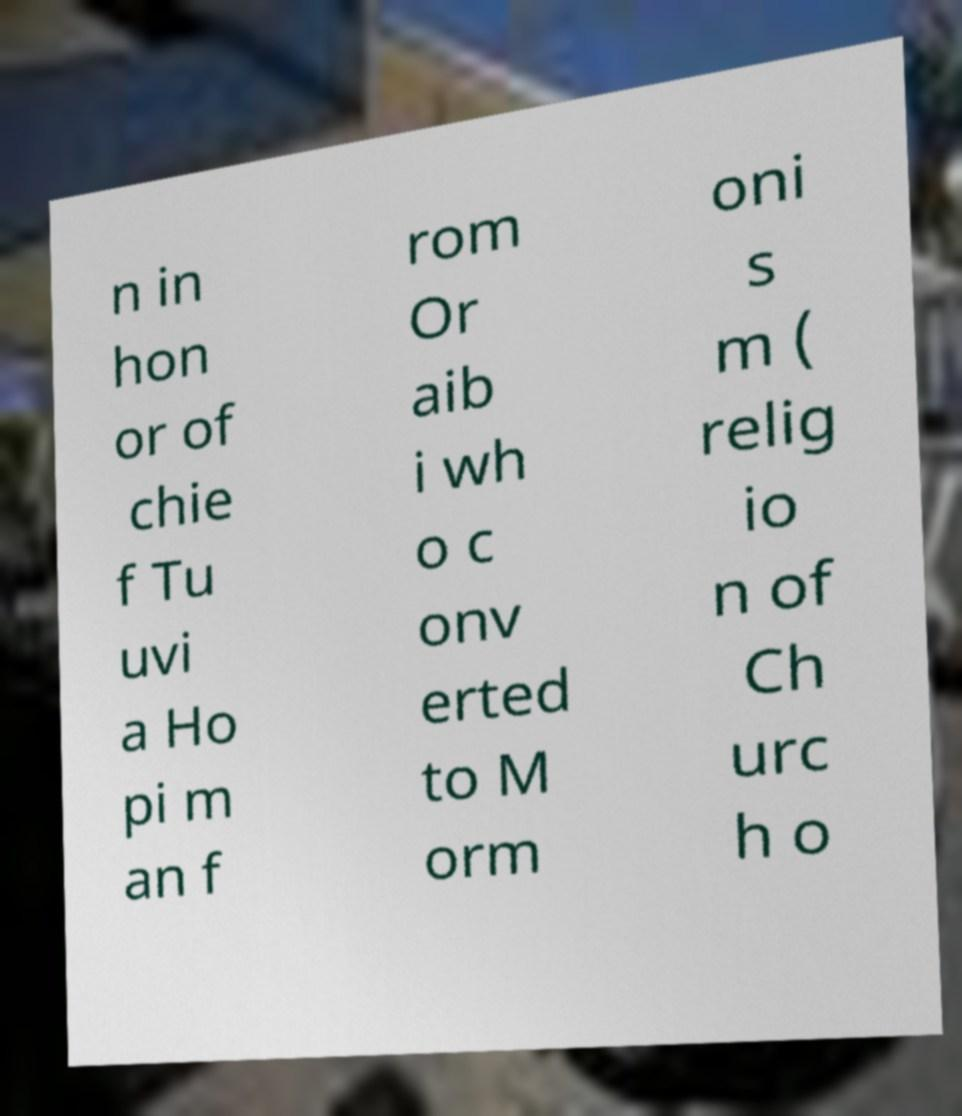For documentation purposes, I need the text within this image transcribed. Could you provide that? n in hon or of chie f Tu uvi a Ho pi m an f rom Or aib i wh o c onv erted to M orm oni s m ( relig io n of Ch urc h o 